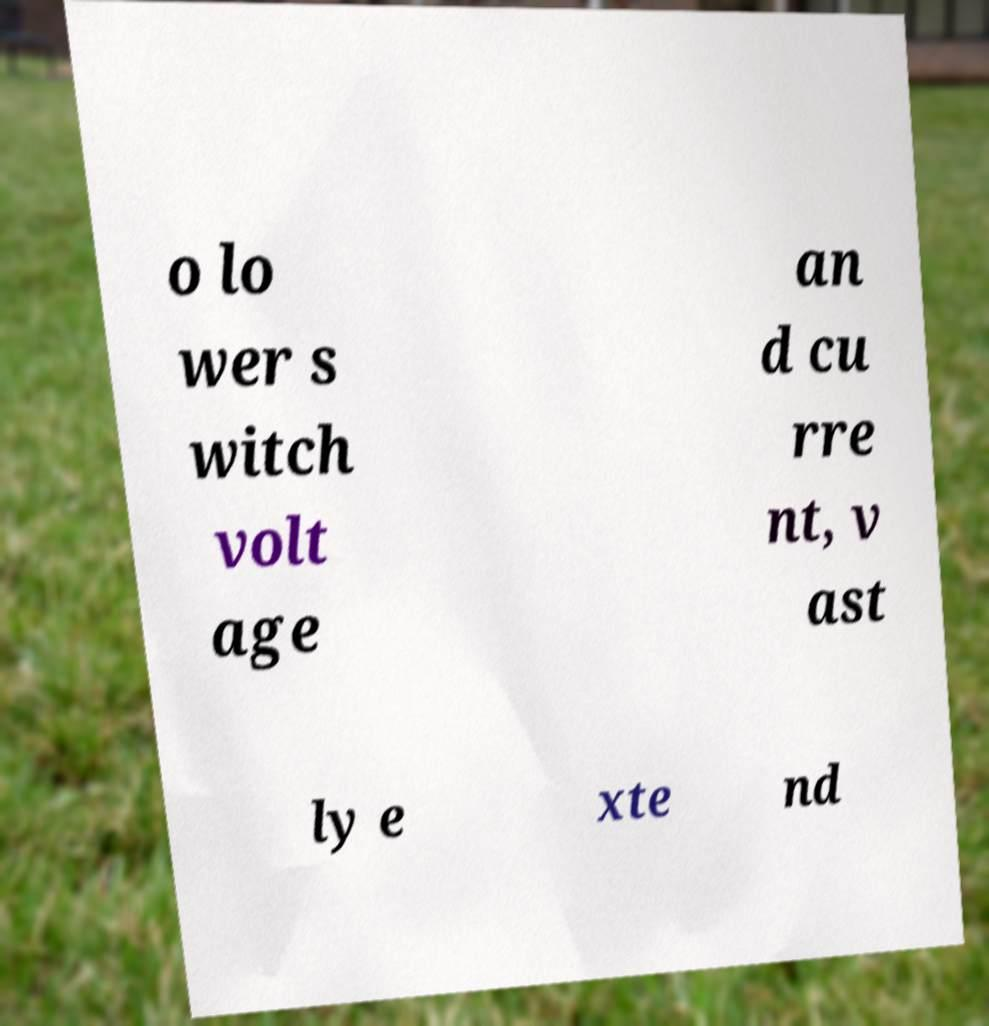There's text embedded in this image that I need extracted. Can you transcribe it verbatim? o lo wer s witch volt age an d cu rre nt, v ast ly e xte nd 